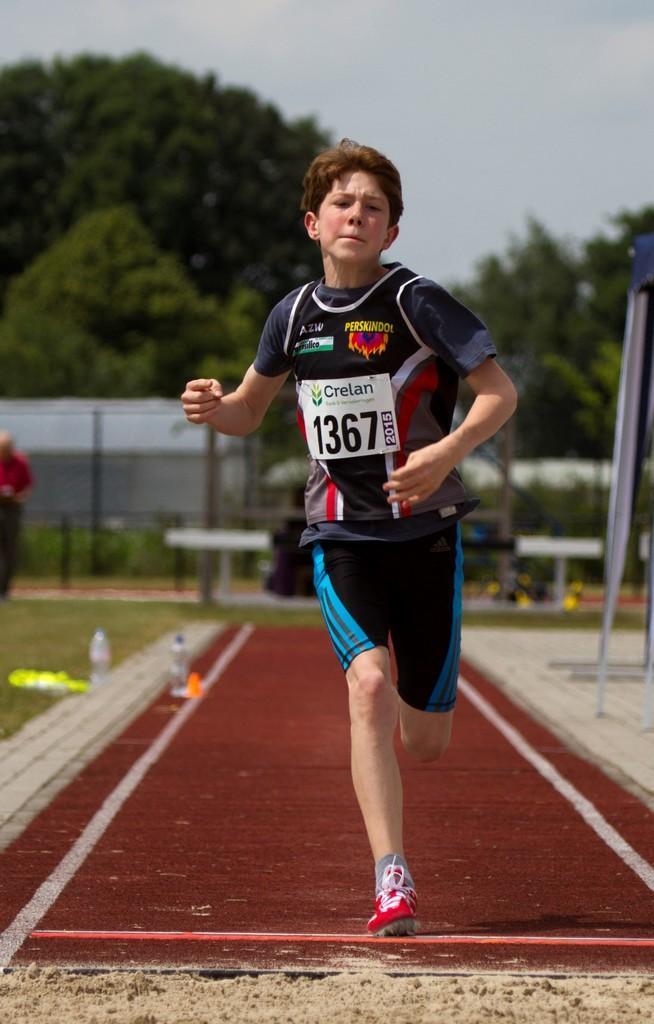Describe this image in one or two sentences. In this picture we can see a boy running on the ground and at the back of him we can see the grass, person, bottles, trees, wall, some objects and in the background we can see the sky. 